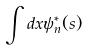<formula> <loc_0><loc_0><loc_500><loc_500>\int d x \psi _ { n } ^ { * } ( s )</formula> 